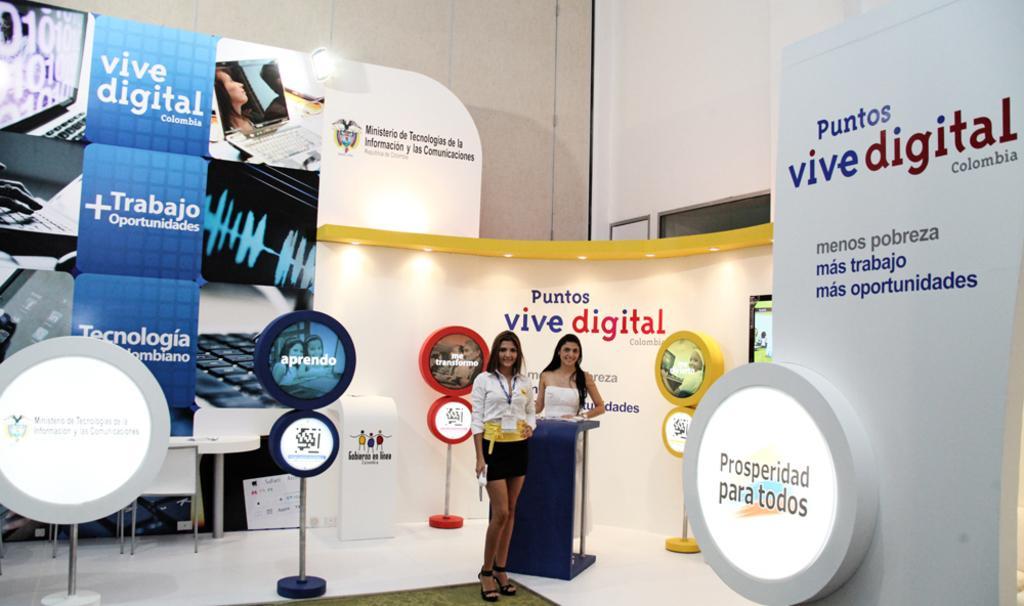How would you summarize this image in a sentence or two? In the middle of the image we can see two women, they both are standing, beside to them we can find few hoardings and a light, and also we can see few chairs and a table. 